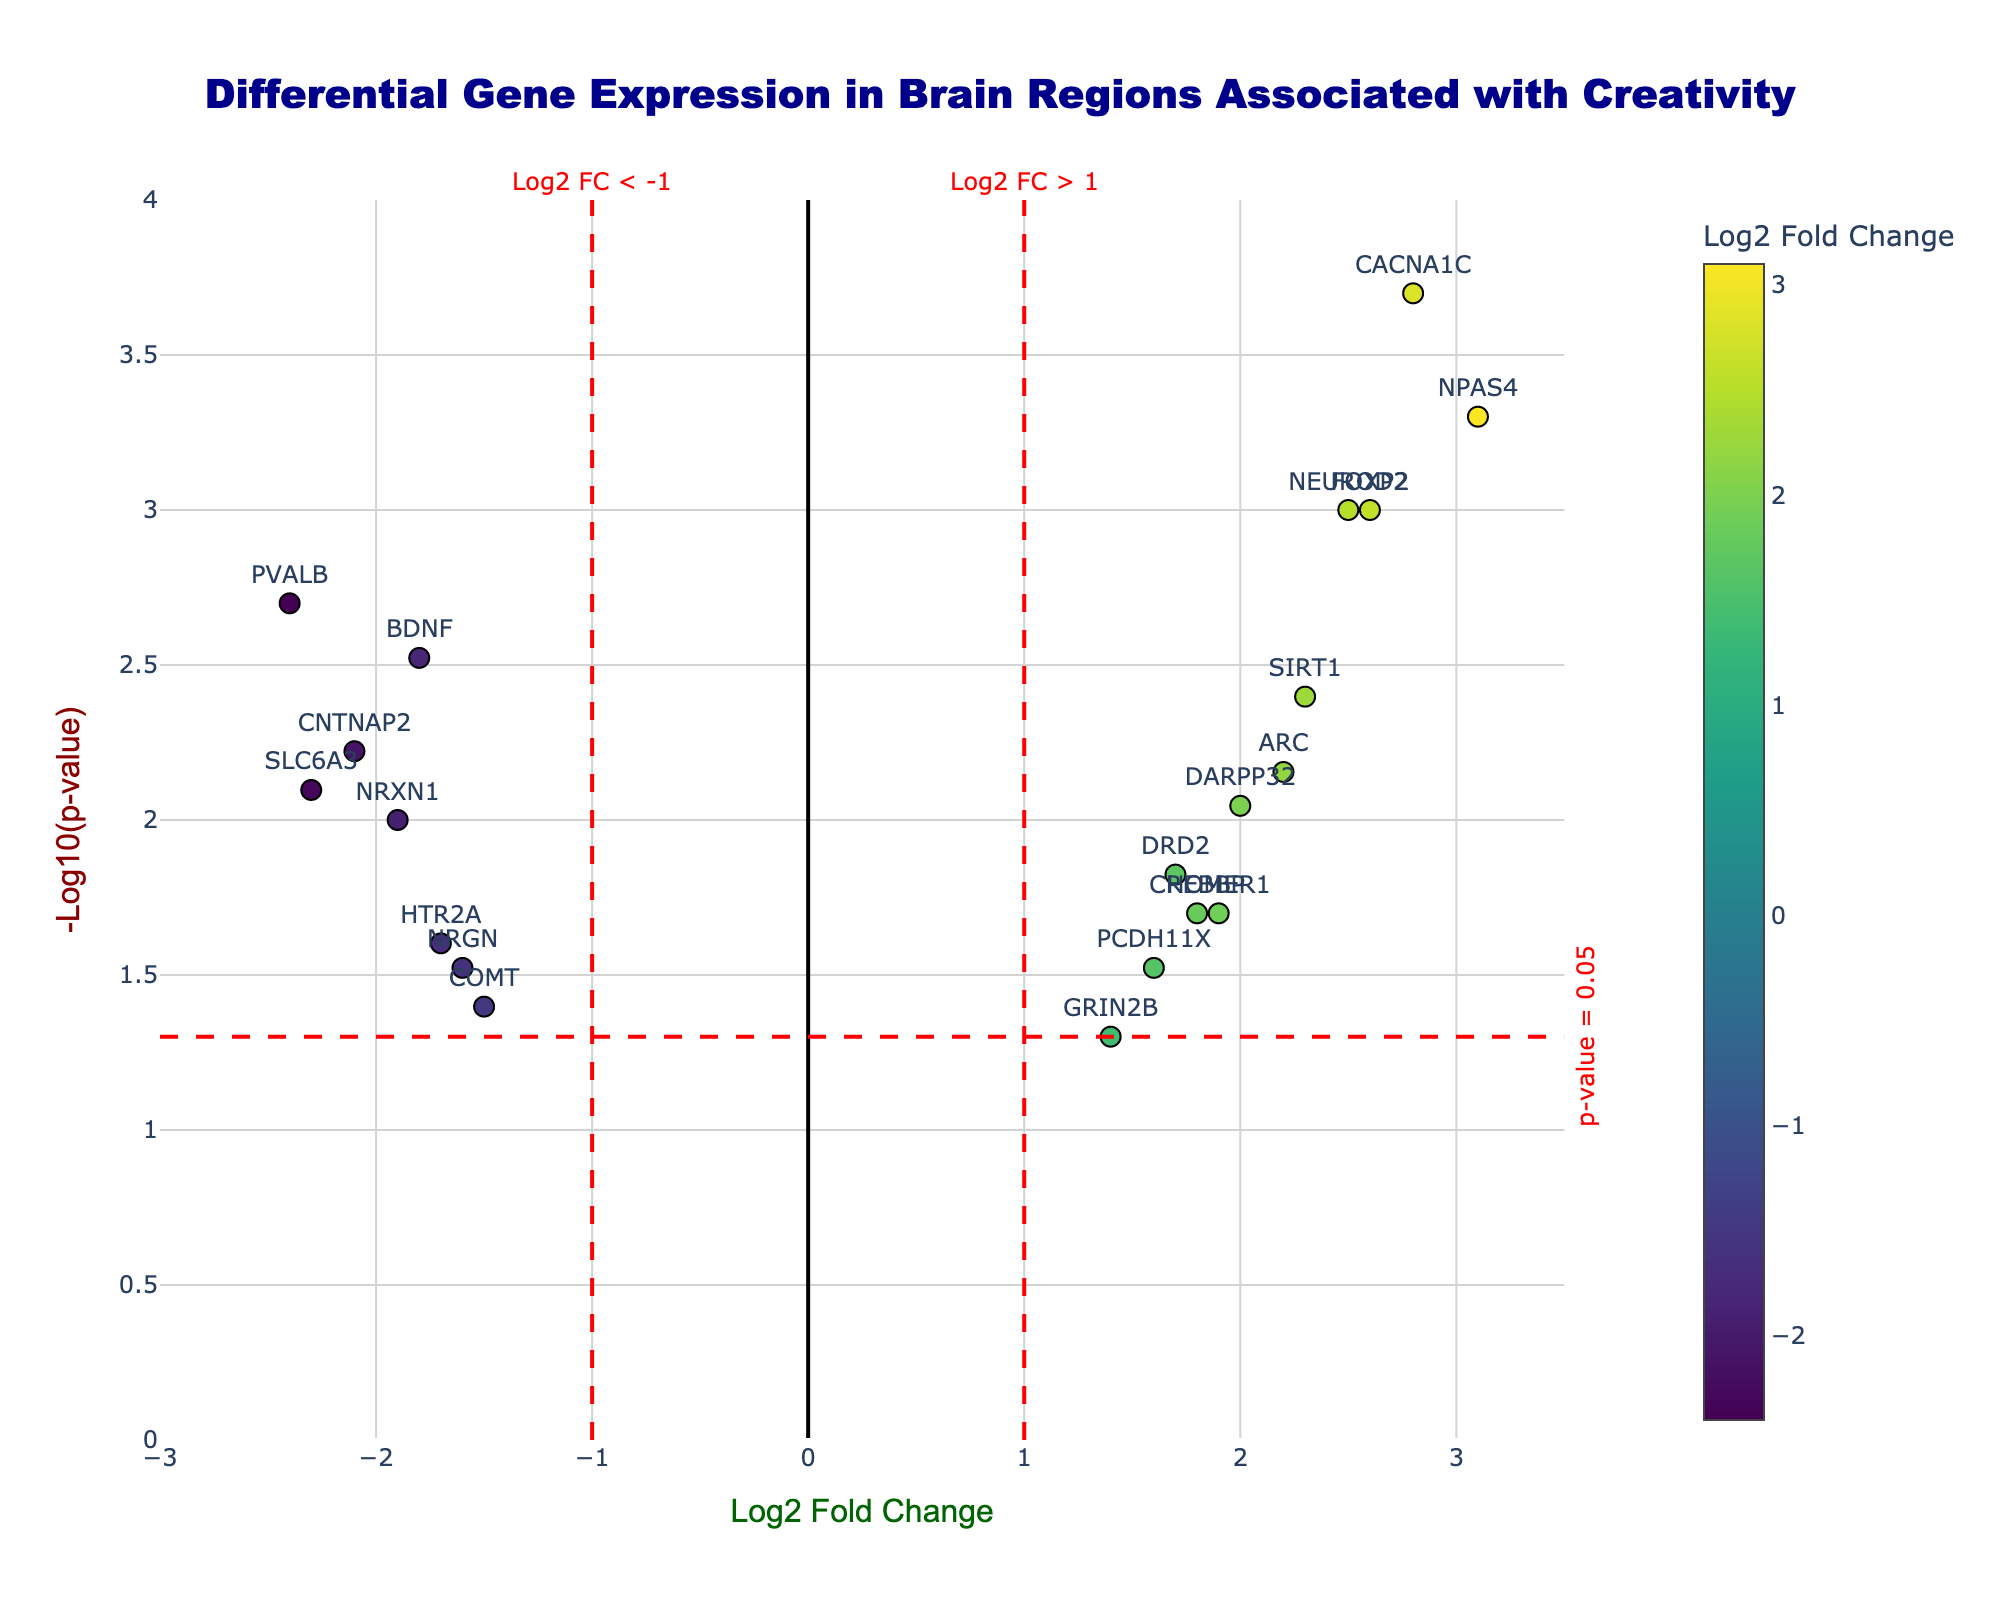What is the title of the plot? The title is usually displayed at the top center of the plot. In this case, it reads "Differential Gene Expression in Brain Regions Associated with Creativity."
Answer: Differential Gene Expression in Brain Regions Associated with Creativity What are the x-axis and y-axis labels? The labels on the axes are typically found on the plot edges. The x-axis is labeled "Log2 Fold Change," and the y-axis is labeled "-Log10(p-value)."
Answer: Log2 Fold Change and -Log10(p-value) Which gene has the highest log2 fold change and what is its value? To determine the gene with the highest log2 fold change, identify the point farthest to the right on the x-axis. The NPAS4 gene has the highest log2 fold change with a value of 3.1.
Answer: NPAS4, 3.1 How many genes have a significant p-value below 0.05? Significant p-values (below 0.05) correspond to points above the horizontal red dashed line (-log10(0.05) ≈ 1.301). Counting these points gives the number of significant genes, which is 15.
Answer: 15 Which genes have a log2 fold change between -1 and 1? To find these genes, look for points between -1 and 1 on the x-axis. GRIN2B and HTR2A are within this range.
Answer: GRIN2B, HTR2A Which gene with a positive log2 fold change has the lowest p-value? Focus on the positive side of the x-axis and find the point with the highest position on the y-axis. CACNA1C has a positive log2 fold change of 2.8 and a p-value of 0.0002, hence the lowest.
Answer: CACNA1C What is the range of log2 fold change for the genes shown in the plot? The range can be determined by identifying the minimum and maximum x-axis values. The smallest log2 fold change is approximately -2.4 (PVALB) and the largest is 3.1 (NPAS4).
Answer: -2.4 to 3.1 Which gene has the highest -log10(p-value) and what is its p-value? The highest -log10(p-value) is the point at the topmost position on the y-axis. NPAS4 has the highest -log10(p-value) with y-value ≈ 3.301 and p-value of 0.0005.
Answer: NPAS4, 0.0005 Which genes have a log2 fold change less than -2? Look on the left side of the x-axis for points below -2. Genes meeting this criterion are SLC6A3 and PVALB.
Answer: SLC6A3, PVALB How many genes have a p-value equal to or less than 0.01 and a log2 fold change greater than 1? Find points higher than the horizontal threshold line (-log10(0.01) ≈ 2) above the red vertical line (log2 FC > 1). These genes are NPAS4, CACNA1C, and FOXP2.
Answer: 3 